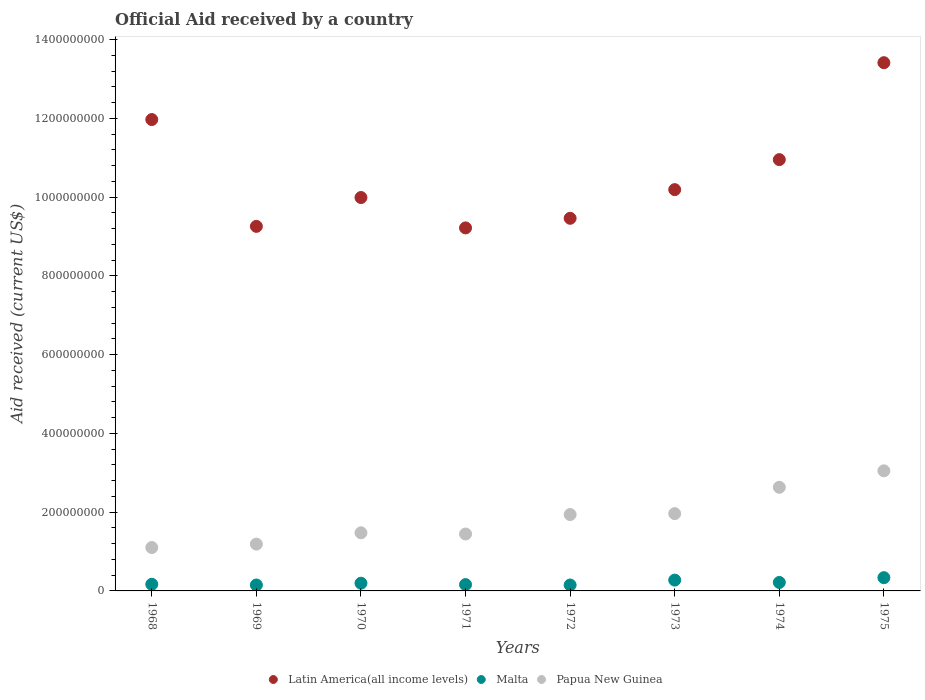How many different coloured dotlines are there?
Offer a terse response. 3. What is the net official aid received in Malta in 1971?
Provide a succinct answer. 1.60e+07. Across all years, what is the maximum net official aid received in Malta?
Your answer should be very brief. 3.36e+07. Across all years, what is the minimum net official aid received in Malta?
Give a very brief answer. 1.50e+07. In which year was the net official aid received in Malta maximum?
Give a very brief answer. 1975. In which year was the net official aid received in Malta minimum?
Offer a very short reply. 1972. What is the total net official aid received in Papua New Guinea in the graph?
Provide a short and direct response. 1.48e+09. What is the difference between the net official aid received in Latin America(all income levels) in 1972 and that in 1975?
Offer a terse response. -3.95e+08. What is the difference between the net official aid received in Latin America(all income levels) in 1971 and the net official aid received in Papua New Guinea in 1968?
Provide a short and direct response. 8.12e+08. What is the average net official aid received in Latin America(all income levels) per year?
Your answer should be compact. 1.06e+09. In the year 1971, what is the difference between the net official aid received in Malta and net official aid received in Papua New Guinea?
Your answer should be very brief. -1.29e+08. In how many years, is the net official aid received in Malta greater than 1320000000 US$?
Make the answer very short. 0. What is the ratio of the net official aid received in Latin America(all income levels) in 1968 to that in 1969?
Keep it short and to the point. 1.29. Is the net official aid received in Malta in 1970 less than that in 1975?
Give a very brief answer. Yes. Is the difference between the net official aid received in Malta in 1968 and 1970 greater than the difference between the net official aid received in Papua New Guinea in 1968 and 1970?
Your answer should be compact. Yes. What is the difference between the highest and the second highest net official aid received in Malta?
Make the answer very short. 6.16e+06. What is the difference between the highest and the lowest net official aid received in Papua New Guinea?
Provide a succinct answer. 1.95e+08. In how many years, is the net official aid received in Latin America(all income levels) greater than the average net official aid received in Latin America(all income levels) taken over all years?
Provide a short and direct response. 3. Is the sum of the net official aid received in Malta in 1970 and 1973 greater than the maximum net official aid received in Papua New Guinea across all years?
Your response must be concise. No. Is it the case that in every year, the sum of the net official aid received in Malta and net official aid received in Latin America(all income levels)  is greater than the net official aid received in Papua New Guinea?
Ensure brevity in your answer.  Yes. Is the net official aid received in Malta strictly greater than the net official aid received in Latin America(all income levels) over the years?
Ensure brevity in your answer.  No. How many dotlines are there?
Your answer should be very brief. 3. Where does the legend appear in the graph?
Your response must be concise. Bottom center. How many legend labels are there?
Your answer should be compact. 3. What is the title of the graph?
Your response must be concise. Official Aid received by a country. What is the label or title of the X-axis?
Offer a terse response. Years. What is the label or title of the Y-axis?
Ensure brevity in your answer.  Aid received (current US$). What is the Aid received (current US$) in Latin America(all income levels) in 1968?
Keep it short and to the point. 1.20e+09. What is the Aid received (current US$) in Malta in 1968?
Offer a very short reply. 1.68e+07. What is the Aid received (current US$) in Papua New Guinea in 1968?
Make the answer very short. 1.10e+08. What is the Aid received (current US$) of Latin America(all income levels) in 1969?
Offer a terse response. 9.26e+08. What is the Aid received (current US$) in Malta in 1969?
Provide a short and direct response. 1.50e+07. What is the Aid received (current US$) of Papua New Guinea in 1969?
Your answer should be very brief. 1.19e+08. What is the Aid received (current US$) of Latin America(all income levels) in 1970?
Your answer should be very brief. 9.99e+08. What is the Aid received (current US$) of Malta in 1970?
Ensure brevity in your answer.  1.96e+07. What is the Aid received (current US$) in Papua New Guinea in 1970?
Offer a very short reply. 1.48e+08. What is the Aid received (current US$) in Latin America(all income levels) in 1971?
Your answer should be compact. 9.22e+08. What is the Aid received (current US$) in Malta in 1971?
Your answer should be very brief. 1.60e+07. What is the Aid received (current US$) of Papua New Guinea in 1971?
Your response must be concise. 1.45e+08. What is the Aid received (current US$) in Latin America(all income levels) in 1972?
Your answer should be compact. 9.46e+08. What is the Aid received (current US$) in Malta in 1972?
Your response must be concise. 1.50e+07. What is the Aid received (current US$) in Papua New Guinea in 1972?
Your answer should be very brief. 1.94e+08. What is the Aid received (current US$) of Latin America(all income levels) in 1973?
Give a very brief answer. 1.02e+09. What is the Aid received (current US$) of Malta in 1973?
Keep it short and to the point. 2.75e+07. What is the Aid received (current US$) of Papua New Guinea in 1973?
Provide a succinct answer. 1.96e+08. What is the Aid received (current US$) in Latin America(all income levels) in 1974?
Offer a terse response. 1.10e+09. What is the Aid received (current US$) of Malta in 1974?
Your answer should be very brief. 2.15e+07. What is the Aid received (current US$) in Papua New Guinea in 1974?
Offer a very short reply. 2.63e+08. What is the Aid received (current US$) of Latin America(all income levels) in 1975?
Provide a succinct answer. 1.34e+09. What is the Aid received (current US$) in Malta in 1975?
Ensure brevity in your answer.  3.36e+07. What is the Aid received (current US$) of Papua New Guinea in 1975?
Make the answer very short. 3.05e+08. Across all years, what is the maximum Aid received (current US$) in Latin America(all income levels)?
Keep it short and to the point. 1.34e+09. Across all years, what is the maximum Aid received (current US$) in Malta?
Provide a short and direct response. 3.36e+07. Across all years, what is the maximum Aid received (current US$) of Papua New Guinea?
Keep it short and to the point. 3.05e+08. Across all years, what is the minimum Aid received (current US$) of Latin America(all income levels)?
Offer a terse response. 9.22e+08. Across all years, what is the minimum Aid received (current US$) in Malta?
Give a very brief answer. 1.50e+07. Across all years, what is the minimum Aid received (current US$) in Papua New Guinea?
Offer a terse response. 1.10e+08. What is the total Aid received (current US$) of Latin America(all income levels) in the graph?
Keep it short and to the point. 8.45e+09. What is the total Aid received (current US$) of Malta in the graph?
Keep it short and to the point. 1.65e+08. What is the total Aid received (current US$) of Papua New Guinea in the graph?
Offer a very short reply. 1.48e+09. What is the difference between the Aid received (current US$) of Latin America(all income levels) in 1968 and that in 1969?
Give a very brief answer. 2.71e+08. What is the difference between the Aid received (current US$) of Malta in 1968 and that in 1969?
Your response must be concise. 1.80e+06. What is the difference between the Aid received (current US$) of Papua New Guinea in 1968 and that in 1969?
Give a very brief answer. -8.67e+06. What is the difference between the Aid received (current US$) of Latin America(all income levels) in 1968 and that in 1970?
Give a very brief answer. 1.98e+08. What is the difference between the Aid received (current US$) in Malta in 1968 and that in 1970?
Ensure brevity in your answer.  -2.71e+06. What is the difference between the Aid received (current US$) in Papua New Guinea in 1968 and that in 1970?
Your answer should be compact. -3.74e+07. What is the difference between the Aid received (current US$) in Latin America(all income levels) in 1968 and that in 1971?
Your answer should be very brief. 2.75e+08. What is the difference between the Aid received (current US$) of Malta in 1968 and that in 1971?
Offer a terse response. 8.10e+05. What is the difference between the Aid received (current US$) in Papua New Guinea in 1968 and that in 1971?
Provide a short and direct response. -3.43e+07. What is the difference between the Aid received (current US$) of Latin America(all income levels) in 1968 and that in 1972?
Ensure brevity in your answer.  2.51e+08. What is the difference between the Aid received (current US$) in Malta in 1968 and that in 1972?
Your answer should be very brief. 1.81e+06. What is the difference between the Aid received (current US$) in Papua New Guinea in 1968 and that in 1972?
Offer a terse response. -8.37e+07. What is the difference between the Aid received (current US$) of Latin America(all income levels) in 1968 and that in 1973?
Offer a very short reply. 1.78e+08. What is the difference between the Aid received (current US$) in Malta in 1968 and that in 1973?
Provide a succinct answer. -1.06e+07. What is the difference between the Aid received (current US$) of Papua New Guinea in 1968 and that in 1973?
Give a very brief answer. -8.61e+07. What is the difference between the Aid received (current US$) in Latin America(all income levels) in 1968 and that in 1974?
Provide a succinct answer. 1.02e+08. What is the difference between the Aid received (current US$) in Malta in 1968 and that in 1974?
Your answer should be very brief. -4.68e+06. What is the difference between the Aid received (current US$) of Papua New Guinea in 1968 and that in 1974?
Your answer should be very brief. -1.53e+08. What is the difference between the Aid received (current US$) of Latin America(all income levels) in 1968 and that in 1975?
Offer a very short reply. -1.44e+08. What is the difference between the Aid received (current US$) in Malta in 1968 and that in 1975?
Provide a short and direct response. -1.68e+07. What is the difference between the Aid received (current US$) in Papua New Guinea in 1968 and that in 1975?
Provide a short and direct response. -1.95e+08. What is the difference between the Aid received (current US$) in Latin America(all income levels) in 1969 and that in 1970?
Your answer should be very brief. -7.33e+07. What is the difference between the Aid received (current US$) in Malta in 1969 and that in 1970?
Keep it short and to the point. -4.51e+06. What is the difference between the Aid received (current US$) in Papua New Guinea in 1969 and that in 1970?
Make the answer very short. -2.88e+07. What is the difference between the Aid received (current US$) in Latin America(all income levels) in 1969 and that in 1971?
Keep it short and to the point. 3.88e+06. What is the difference between the Aid received (current US$) in Malta in 1969 and that in 1971?
Your answer should be compact. -9.90e+05. What is the difference between the Aid received (current US$) of Papua New Guinea in 1969 and that in 1971?
Provide a succinct answer. -2.57e+07. What is the difference between the Aid received (current US$) of Latin America(all income levels) in 1969 and that in 1972?
Offer a very short reply. -2.05e+07. What is the difference between the Aid received (current US$) of Malta in 1969 and that in 1972?
Your answer should be compact. 10000. What is the difference between the Aid received (current US$) of Papua New Guinea in 1969 and that in 1972?
Make the answer very short. -7.51e+07. What is the difference between the Aid received (current US$) in Latin America(all income levels) in 1969 and that in 1973?
Provide a short and direct response. -9.33e+07. What is the difference between the Aid received (current US$) of Malta in 1969 and that in 1973?
Your answer should be compact. -1.24e+07. What is the difference between the Aid received (current US$) in Papua New Guinea in 1969 and that in 1973?
Keep it short and to the point. -7.74e+07. What is the difference between the Aid received (current US$) of Latin America(all income levels) in 1969 and that in 1974?
Your answer should be very brief. -1.70e+08. What is the difference between the Aid received (current US$) of Malta in 1969 and that in 1974?
Provide a short and direct response. -6.48e+06. What is the difference between the Aid received (current US$) of Papua New Guinea in 1969 and that in 1974?
Make the answer very short. -1.44e+08. What is the difference between the Aid received (current US$) of Latin America(all income levels) in 1969 and that in 1975?
Provide a succinct answer. -4.16e+08. What is the difference between the Aid received (current US$) of Malta in 1969 and that in 1975?
Offer a terse response. -1.86e+07. What is the difference between the Aid received (current US$) in Papua New Guinea in 1969 and that in 1975?
Give a very brief answer. -1.86e+08. What is the difference between the Aid received (current US$) of Latin America(all income levels) in 1970 and that in 1971?
Provide a short and direct response. 7.72e+07. What is the difference between the Aid received (current US$) in Malta in 1970 and that in 1971?
Provide a short and direct response. 3.52e+06. What is the difference between the Aid received (current US$) of Papua New Guinea in 1970 and that in 1971?
Provide a succinct answer. 3.10e+06. What is the difference between the Aid received (current US$) of Latin America(all income levels) in 1970 and that in 1972?
Your response must be concise. 5.28e+07. What is the difference between the Aid received (current US$) in Malta in 1970 and that in 1972?
Your response must be concise. 4.52e+06. What is the difference between the Aid received (current US$) of Papua New Guinea in 1970 and that in 1972?
Your response must be concise. -4.63e+07. What is the difference between the Aid received (current US$) of Latin America(all income levels) in 1970 and that in 1973?
Provide a succinct answer. -2.01e+07. What is the difference between the Aid received (current US$) in Malta in 1970 and that in 1973?
Make the answer very short. -7.93e+06. What is the difference between the Aid received (current US$) in Papua New Guinea in 1970 and that in 1973?
Give a very brief answer. -4.87e+07. What is the difference between the Aid received (current US$) in Latin America(all income levels) in 1970 and that in 1974?
Make the answer very short. -9.63e+07. What is the difference between the Aid received (current US$) in Malta in 1970 and that in 1974?
Offer a terse response. -1.97e+06. What is the difference between the Aid received (current US$) of Papua New Guinea in 1970 and that in 1974?
Keep it short and to the point. -1.16e+08. What is the difference between the Aid received (current US$) in Latin America(all income levels) in 1970 and that in 1975?
Offer a terse response. -3.42e+08. What is the difference between the Aid received (current US$) in Malta in 1970 and that in 1975?
Provide a succinct answer. -1.41e+07. What is the difference between the Aid received (current US$) in Papua New Guinea in 1970 and that in 1975?
Provide a short and direct response. -1.57e+08. What is the difference between the Aid received (current US$) in Latin America(all income levels) in 1971 and that in 1972?
Provide a succinct answer. -2.44e+07. What is the difference between the Aid received (current US$) in Papua New Guinea in 1971 and that in 1972?
Ensure brevity in your answer.  -4.94e+07. What is the difference between the Aid received (current US$) of Latin America(all income levels) in 1971 and that in 1973?
Ensure brevity in your answer.  -9.72e+07. What is the difference between the Aid received (current US$) of Malta in 1971 and that in 1973?
Your answer should be compact. -1.14e+07. What is the difference between the Aid received (current US$) of Papua New Guinea in 1971 and that in 1973?
Provide a short and direct response. -5.18e+07. What is the difference between the Aid received (current US$) in Latin America(all income levels) in 1971 and that in 1974?
Make the answer very short. -1.73e+08. What is the difference between the Aid received (current US$) of Malta in 1971 and that in 1974?
Provide a succinct answer. -5.49e+06. What is the difference between the Aid received (current US$) of Papua New Guinea in 1971 and that in 1974?
Ensure brevity in your answer.  -1.19e+08. What is the difference between the Aid received (current US$) in Latin America(all income levels) in 1971 and that in 1975?
Your answer should be compact. -4.20e+08. What is the difference between the Aid received (current US$) of Malta in 1971 and that in 1975?
Your answer should be very brief. -1.76e+07. What is the difference between the Aid received (current US$) of Papua New Guinea in 1971 and that in 1975?
Provide a short and direct response. -1.60e+08. What is the difference between the Aid received (current US$) of Latin America(all income levels) in 1972 and that in 1973?
Provide a short and direct response. -7.28e+07. What is the difference between the Aid received (current US$) in Malta in 1972 and that in 1973?
Offer a very short reply. -1.24e+07. What is the difference between the Aid received (current US$) in Papua New Guinea in 1972 and that in 1973?
Offer a very short reply. -2.37e+06. What is the difference between the Aid received (current US$) of Latin America(all income levels) in 1972 and that in 1974?
Your answer should be compact. -1.49e+08. What is the difference between the Aid received (current US$) of Malta in 1972 and that in 1974?
Offer a terse response. -6.49e+06. What is the difference between the Aid received (current US$) of Papua New Guinea in 1972 and that in 1974?
Make the answer very short. -6.92e+07. What is the difference between the Aid received (current US$) in Latin America(all income levels) in 1972 and that in 1975?
Make the answer very short. -3.95e+08. What is the difference between the Aid received (current US$) in Malta in 1972 and that in 1975?
Your answer should be compact. -1.86e+07. What is the difference between the Aid received (current US$) of Papua New Guinea in 1972 and that in 1975?
Offer a very short reply. -1.11e+08. What is the difference between the Aid received (current US$) of Latin America(all income levels) in 1973 and that in 1974?
Your answer should be very brief. -7.62e+07. What is the difference between the Aid received (current US$) of Malta in 1973 and that in 1974?
Give a very brief answer. 5.96e+06. What is the difference between the Aid received (current US$) in Papua New Guinea in 1973 and that in 1974?
Make the answer very short. -6.68e+07. What is the difference between the Aid received (current US$) of Latin America(all income levels) in 1973 and that in 1975?
Offer a very short reply. -3.22e+08. What is the difference between the Aid received (current US$) of Malta in 1973 and that in 1975?
Provide a short and direct response. -6.16e+06. What is the difference between the Aid received (current US$) in Papua New Guinea in 1973 and that in 1975?
Provide a succinct answer. -1.09e+08. What is the difference between the Aid received (current US$) of Latin America(all income levels) in 1974 and that in 1975?
Keep it short and to the point. -2.46e+08. What is the difference between the Aid received (current US$) in Malta in 1974 and that in 1975?
Offer a very short reply. -1.21e+07. What is the difference between the Aid received (current US$) in Papua New Guinea in 1974 and that in 1975?
Give a very brief answer. -4.18e+07. What is the difference between the Aid received (current US$) in Latin America(all income levels) in 1968 and the Aid received (current US$) in Malta in 1969?
Your answer should be very brief. 1.18e+09. What is the difference between the Aid received (current US$) in Latin America(all income levels) in 1968 and the Aid received (current US$) in Papua New Guinea in 1969?
Provide a succinct answer. 1.08e+09. What is the difference between the Aid received (current US$) in Malta in 1968 and the Aid received (current US$) in Papua New Guinea in 1969?
Provide a succinct answer. -1.02e+08. What is the difference between the Aid received (current US$) of Latin America(all income levels) in 1968 and the Aid received (current US$) of Malta in 1970?
Provide a succinct answer. 1.18e+09. What is the difference between the Aid received (current US$) in Latin America(all income levels) in 1968 and the Aid received (current US$) in Papua New Guinea in 1970?
Keep it short and to the point. 1.05e+09. What is the difference between the Aid received (current US$) in Malta in 1968 and the Aid received (current US$) in Papua New Guinea in 1970?
Your answer should be very brief. -1.31e+08. What is the difference between the Aid received (current US$) in Latin America(all income levels) in 1968 and the Aid received (current US$) in Malta in 1971?
Make the answer very short. 1.18e+09. What is the difference between the Aid received (current US$) of Latin America(all income levels) in 1968 and the Aid received (current US$) of Papua New Guinea in 1971?
Your answer should be compact. 1.05e+09. What is the difference between the Aid received (current US$) of Malta in 1968 and the Aid received (current US$) of Papua New Guinea in 1971?
Provide a succinct answer. -1.28e+08. What is the difference between the Aid received (current US$) of Latin America(all income levels) in 1968 and the Aid received (current US$) of Malta in 1972?
Make the answer very short. 1.18e+09. What is the difference between the Aid received (current US$) in Latin America(all income levels) in 1968 and the Aid received (current US$) in Papua New Guinea in 1972?
Provide a short and direct response. 1.00e+09. What is the difference between the Aid received (current US$) in Malta in 1968 and the Aid received (current US$) in Papua New Guinea in 1972?
Ensure brevity in your answer.  -1.77e+08. What is the difference between the Aid received (current US$) of Latin America(all income levels) in 1968 and the Aid received (current US$) of Malta in 1973?
Provide a succinct answer. 1.17e+09. What is the difference between the Aid received (current US$) in Latin America(all income levels) in 1968 and the Aid received (current US$) in Papua New Guinea in 1973?
Your answer should be very brief. 1.00e+09. What is the difference between the Aid received (current US$) in Malta in 1968 and the Aid received (current US$) in Papua New Guinea in 1973?
Provide a succinct answer. -1.79e+08. What is the difference between the Aid received (current US$) of Latin America(all income levels) in 1968 and the Aid received (current US$) of Malta in 1974?
Give a very brief answer. 1.18e+09. What is the difference between the Aid received (current US$) of Latin America(all income levels) in 1968 and the Aid received (current US$) of Papua New Guinea in 1974?
Your answer should be compact. 9.34e+08. What is the difference between the Aid received (current US$) of Malta in 1968 and the Aid received (current US$) of Papua New Guinea in 1974?
Your response must be concise. -2.46e+08. What is the difference between the Aid received (current US$) of Latin America(all income levels) in 1968 and the Aid received (current US$) of Malta in 1975?
Make the answer very short. 1.16e+09. What is the difference between the Aid received (current US$) in Latin America(all income levels) in 1968 and the Aid received (current US$) in Papua New Guinea in 1975?
Offer a terse response. 8.92e+08. What is the difference between the Aid received (current US$) of Malta in 1968 and the Aid received (current US$) of Papua New Guinea in 1975?
Offer a terse response. -2.88e+08. What is the difference between the Aid received (current US$) of Latin America(all income levels) in 1969 and the Aid received (current US$) of Malta in 1970?
Make the answer very short. 9.06e+08. What is the difference between the Aid received (current US$) of Latin America(all income levels) in 1969 and the Aid received (current US$) of Papua New Guinea in 1970?
Your answer should be very brief. 7.78e+08. What is the difference between the Aid received (current US$) in Malta in 1969 and the Aid received (current US$) in Papua New Guinea in 1970?
Make the answer very short. -1.33e+08. What is the difference between the Aid received (current US$) in Latin America(all income levels) in 1969 and the Aid received (current US$) in Malta in 1971?
Give a very brief answer. 9.10e+08. What is the difference between the Aid received (current US$) of Latin America(all income levels) in 1969 and the Aid received (current US$) of Papua New Guinea in 1971?
Your answer should be compact. 7.81e+08. What is the difference between the Aid received (current US$) in Malta in 1969 and the Aid received (current US$) in Papua New Guinea in 1971?
Your response must be concise. -1.30e+08. What is the difference between the Aid received (current US$) of Latin America(all income levels) in 1969 and the Aid received (current US$) of Malta in 1972?
Provide a succinct answer. 9.11e+08. What is the difference between the Aid received (current US$) of Latin America(all income levels) in 1969 and the Aid received (current US$) of Papua New Guinea in 1972?
Keep it short and to the point. 7.32e+08. What is the difference between the Aid received (current US$) of Malta in 1969 and the Aid received (current US$) of Papua New Guinea in 1972?
Your response must be concise. -1.79e+08. What is the difference between the Aid received (current US$) in Latin America(all income levels) in 1969 and the Aid received (current US$) in Malta in 1973?
Offer a very short reply. 8.98e+08. What is the difference between the Aid received (current US$) in Latin America(all income levels) in 1969 and the Aid received (current US$) in Papua New Guinea in 1973?
Make the answer very short. 7.30e+08. What is the difference between the Aid received (current US$) of Malta in 1969 and the Aid received (current US$) of Papua New Guinea in 1973?
Offer a terse response. -1.81e+08. What is the difference between the Aid received (current US$) of Latin America(all income levels) in 1969 and the Aid received (current US$) of Malta in 1974?
Your response must be concise. 9.04e+08. What is the difference between the Aid received (current US$) in Latin America(all income levels) in 1969 and the Aid received (current US$) in Papua New Guinea in 1974?
Provide a succinct answer. 6.63e+08. What is the difference between the Aid received (current US$) in Malta in 1969 and the Aid received (current US$) in Papua New Guinea in 1974?
Ensure brevity in your answer.  -2.48e+08. What is the difference between the Aid received (current US$) of Latin America(all income levels) in 1969 and the Aid received (current US$) of Malta in 1975?
Provide a short and direct response. 8.92e+08. What is the difference between the Aid received (current US$) in Latin America(all income levels) in 1969 and the Aid received (current US$) in Papua New Guinea in 1975?
Provide a succinct answer. 6.21e+08. What is the difference between the Aid received (current US$) in Malta in 1969 and the Aid received (current US$) in Papua New Guinea in 1975?
Your answer should be compact. -2.90e+08. What is the difference between the Aid received (current US$) of Latin America(all income levels) in 1970 and the Aid received (current US$) of Malta in 1971?
Offer a very short reply. 9.83e+08. What is the difference between the Aid received (current US$) of Latin America(all income levels) in 1970 and the Aid received (current US$) of Papua New Guinea in 1971?
Keep it short and to the point. 8.55e+08. What is the difference between the Aid received (current US$) in Malta in 1970 and the Aid received (current US$) in Papua New Guinea in 1971?
Keep it short and to the point. -1.25e+08. What is the difference between the Aid received (current US$) of Latin America(all income levels) in 1970 and the Aid received (current US$) of Malta in 1972?
Keep it short and to the point. 9.84e+08. What is the difference between the Aid received (current US$) in Latin America(all income levels) in 1970 and the Aid received (current US$) in Papua New Guinea in 1972?
Offer a terse response. 8.05e+08. What is the difference between the Aid received (current US$) of Malta in 1970 and the Aid received (current US$) of Papua New Guinea in 1972?
Provide a short and direct response. -1.74e+08. What is the difference between the Aid received (current US$) in Latin America(all income levels) in 1970 and the Aid received (current US$) in Malta in 1973?
Give a very brief answer. 9.72e+08. What is the difference between the Aid received (current US$) in Latin America(all income levels) in 1970 and the Aid received (current US$) in Papua New Guinea in 1973?
Provide a short and direct response. 8.03e+08. What is the difference between the Aid received (current US$) in Malta in 1970 and the Aid received (current US$) in Papua New Guinea in 1973?
Your answer should be compact. -1.77e+08. What is the difference between the Aid received (current US$) in Latin America(all income levels) in 1970 and the Aid received (current US$) in Malta in 1974?
Offer a terse response. 9.78e+08. What is the difference between the Aid received (current US$) in Latin America(all income levels) in 1970 and the Aid received (current US$) in Papua New Guinea in 1974?
Your response must be concise. 7.36e+08. What is the difference between the Aid received (current US$) in Malta in 1970 and the Aid received (current US$) in Papua New Guinea in 1974?
Your response must be concise. -2.44e+08. What is the difference between the Aid received (current US$) in Latin America(all income levels) in 1970 and the Aid received (current US$) in Malta in 1975?
Make the answer very short. 9.66e+08. What is the difference between the Aid received (current US$) in Latin America(all income levels) in 1970 and the Aid received (current US$) in Papua New Guinea in 1975?
Ensure brevity in your answer.  6.94e+08. What is the difference between the Aid received (current US$) of Malta in 1970 and the Aid received (current US$) of Papua New Guinea in 1975?
Offer a terse response. -2.85e+08. What is the difference between the Aid received (current US$) in Latin America(all income levels) in 1971 and the Aid received (current US$) in Malta in 1972?
Your answer should be compact. 9.07e+08. What is the difference between the Aid received (current US$) in Latin America(all income levels) in 1971 and the Aid received (current US$) in Papua New Guinea in 1972?
Provide a succinct answer. 7.28e+08. What is the difference between the Aid received (current US$) in Malta in 1971 and the Aid received (current US$) in Papua New Guinea in 1972?
Provide a succinct answer. -1.78e+08. What is the difference between the Aid received (current US$) in Latin America(all income levels) in 1971 and the Aid received (current US$) in Malta in 1973?
Give a very brief answer. 8.95e+08. What is the difference between the Aid received (current US$) in Latin America(all income levels) in 1971 and the Aid received (current US$) in Papua New Guinea in 1973?
Your response must be concise. 7.26e+08. What is the difference between the Aid received (current US$) of Malta in 1971 and the Aid received (current US$) of Papua New Guinea in 1973?
Keep it short and to the point. -1.80e+08. What is the difference between the Aid received (current US$) of Latin America(all income levels) in 1971 and the Aid received (current US$) of Malta in 1974?
Make the answer very short. 9.00e+08. What is the difference between the Aid received (current US$) in Latin America(all income levels) in 1971 and the Aid received (current US$) in Papua New Guinea in 1974?
Your answer should be very brief. 6.59e+08. What is the difference between the Aid received (current US$) in Malta in 1971 and the Aid received (current US$) in Papua New Guinea in 1974?
Offer a terse response. -2.47e+08. What is the difference between the Aid received (current US$) of Latin America(all income levels) in 1971 and the Aid received (current US$) of Malta in 1975?
Give a very brief answer. 8.88e+08. What is the difference between the Aid received (current US$) of Latin America(all income levels) in 1971 and the Aid received (current US$) of Papua New Guinea in 1975?
Make the answer very short. 6.17e+08. What is the difference between the Aid received (current US$) in Malta in 1971 and the Aid received (current US$) in Papua New Guinea in 1975?
Make the answer very short. -2.89e+08. What is the difference between the Aid received (current US$) of Latin America(all income levels) in 1972 and the Aid received (current US$) of Malta in 1973?
Ensure brevity in your answer.  9.19e+08. What is the difference between the Aid received (current US$) in Latin America(all income levels) in 1972 and the Aid received (current US$) in Papua New Guinea in 1973?
Offer a terse response. 7.50e+08. What is the difference between the Aid received (current US$) of Malta in 1972 and the Aid received (current US$) of Papua New Guinea in 1973?
Offer a terse response. -1.81e+08. What is the difference between the Aid received (current US$) of Latin America(all income levels) in 1972 and the Aid received (current US$) of Malta in 1974?
Offer a very short reply. 9.25e+08. What is the difference between the Aid received (current US$) of Latin America(all income levels) in 1972 and the Aid received (current US$) of Papua New Guinea in 1974?
Provide a succinct answer. 6.83e+08. What is the difference between the Aid received (current US$) of Malta in 1972 and the Aid received (current US$) of Papua New Guinea in 1974?
Provide a short and direct response. -2.48e+08. What is the difference between the Aid received (current US$) of Latin America(all income levels) in 1972 and the Aid received (current US$) of Malta in 1975?
Your answer should be very brief. 9.13e+08. What is the difference between the Aid received (current US$) in Latin America(all income levels) in 1972 and the Aid received (current US$) in Papua New Guinea in 1975?
Your response must be concise. 6.41e+08. What is the difference between the Aid received (current US$) of Malta in 1972 and the Aid received (current US$) of Papua New Guinea in 1975?
Ensure brevity in your answer.  -2.90e+08. What is the difference between the Aid received (current US$) in Latin America(all income levels) in 1973 and the Aid received (current US$) in Malta in 1974?
Give a very brief answer. 9.98e+08. What is the difference between the Aid received (current US$) of Latin America(all income levels) in 1973 and the Aid received (current US$) of Papua New Guinea in 1974?
Provide a short and direct response. 7.56e+08. What is the difference between the Aid received (current US$) in Malta in 1973 and the Aid received (current US$) in Papua New Guinea in 1974?
Make the answer very short. -2.36e+08. What is the difference between the Aid received (current US$) in Latin America(all income levels) in 1973 and the Aid received (current US$) in Malta in 1975?
Provide a short and direct response. 9.86e+08. What is the difference between the Aid received (current US$) in Latin America(all income levels) in 1973 and the Aid received (current US$) in Papua New Guinea in 1975?
Your answer should be very brief. 7.14e+08. What is the difference between the Aid received (current US$) in Malta in 1973 and the Aid received (current US$) in Papua New Guinea in 1975?
Give a very brief answer. -2.78e+08. What is the difference between the Aid received (current US$) of Latin America(all income levels) in 1974 and the Aid received (current US$) of Malta in 1975?
Make the answer very short. 1.06e+09. What is the difference between the Aid received (current US$) of Latin America(all income levels) in 1974 and the Aid received (current US$) of Papua New Guinea in 1975?
Make the answer very short. 7.90e+08. What is the difference between the Aid received (current US$) in Malta in 1974 and the Aid received (current US$) in Papua New Guinea in 1975?
Your answer should be very brief. -2.83e+08. What is the average Aid received (current US$) in Latin America(all income levels) per year?
Your answer should be compact. 1.06e+09. What is the average Aid received (current US$) in Malta per year?
Offer a very short reply. 2.07e+07. What is the average Aid received (current US$) in Papua New Guinea per year?
Your response must be concise. 1.85e+08. In the year 1968, what is the difference between the Aid received (current US$) of Latin America(all income levels) and Aid received (current US$) of Malta?
Ensure brevity in your answer.  1.18e+09. In the year 1968, what is the difference between the Aid received (current US$) of Latin America(all income levels) and Aid received (current US$) of Papua New Guinea?
Your response must be concise. 1.09e+09. In the year 1968, what is the difference between the Aid received (current US$) of Malta and Aid received (current US$) of Papua New Guinea?
Give a very brief answer. -9.34e+07. In the year 1969, what is the difference between the Aid received (current US$) of Latin America(all income levels) and Aid received (current US$) of Malta?
Offer a very short reply. 9.11e+08. In the year 1969, what is the difference between the Aid received (current US$) of Latin America(all income levels) and Aid received (current US$) of Papua New Guinea?
Keep it short and to the point. 8.07e+08. In the year 1969, what is the difference between the Aid received (current US$) in Malta and Aid received (current US$) in Papua New Guinea?
Keep it short and to the point. -1.04e+08. In the year 1970, what is the difference between the Aid received (current US$) of Latin America(all income levels) and Aid received (current US$) of Malta?
Make the answer very short. 9.80e+08. In the year 1970, what is the difference between the Aid received (current US$) in Latin America(all income levels) and Aid received (current US$) in Papua New Guinea?
Provide a short and direct response. 8.51e+08. In the year 1970, what is the difference between the Aid received (current US$) of Malta and Aid received (current US$) of Papua New Guinea?
Keep it short and to the point. -1.28e+08. In the year 1971, what is the difference between the Aid received (current US$) of Latin America(all income levels) and Aid received (current US$) of Malta?
Keep it short and to the point. 9.06e+08. In the year 1971, what is the difference between the Aid received (current US$) in Latin America(all income levels) and Aid received (current US$) in Papua New Guinea?
Keep it short and to the point. 7.77e+08. In the year 1971, what is the difference between the Aid received (current US$) of Malta and Aid received (current US$) of Papua New Guinea?
Keep it short and to the point. -1.29e+08. In the year 1972, what is the difference between the Aid received (current US$) of Latin America(all income levels) and Aid received (current US$) of Malta?
Provide a short and direct response. 9.31e+08. In the year 1972, what is the difference between the Aid received (current US$) of Latin America(all income levels) and Aid received (current US$) of Papua New Guinea?
Make the answer very short. 7.52e+08. In the year 1972, what is the difference between the Aid received (current US$) of Malta and Aid received (current US$) of Papua New Guinea?
Your answer should be very brief. -1.79e+08. In the year 1973, what is the difference between the Aid received (current US$) in Latin America(all income levels) and Aid received (current US$) in Malta?
Your answer should be very brief. 9.92e+08. In the year 1973, what is the difference between the Aid received (current US$) of Latin America(all income levels) and Aid received (current US$) of Papua New Guinea?
Offer a terse response. 8.23e+08. In the year 1973, what is the difference between the Aid received (current US$) of Malta and Aid received (current US$) of Papua New Guinea?
Your response must be concise. -1.69e+08. In the year 1974, what is the difference between the Aid received (current US$) in Latin America(all income levels) and Aid received (current US$) in Malta?
Your answer should be compact. 1.07e+09. In the year 1974, what is the difference between the Aid received (current US$) of Latin America(all income levels) and Aid received (current US$) of Papua New Guinea?
Your answer should be very brief. 8.32e+08. In the year 1974, what is the difference between the Aid received (current US$) of Malta and Aid received (current US$) of Papua New Guinea?
Your answer should be compact. -2.42e+08. In the year 1975, what is the difference between the Aid received (current US$) in Latin America(all income levels) and Aid received (current US$) in Malta?
Your response must be concise. 1.31e+09. In the year 1975, what is the difference between the Aid received (current US$) in Latin America(all income levels) and Aid received (current US$) in Papua New Guinea?
Offer a terse response. 1.04e+09. In the year 1975, what is the difference between the Aid received (current US$) of Malta and Aid received (current US$) of Papua New Guinea?
Provide a succinct answer. -2.71e+08. What is the ratio of the Aid received (current US$) in Latin America(all income levels) in 1968 to that in 1969?
Make the answer very short. 1.29. What is the ratio of the Aid received (current US$) of Malta in 1968 to that in 1969?
Provide a succinct answer. 1.12. What is the ratio of the Aid received (current US$) in Papua New Guinea in 1968 to that in 1969?
Your answer should be compact. 0.93. What is the ratio of the Aid received (current US$) of Latin America(all income levels) in 1968 to that in 1970?
Make the answer very short. 1.2. What is the ratio of the Aid received (current US$) in Malta in 1968 to that in 1970?
Your answer should be compact. 0.86. What is the ratio of the Aid received (current US$) in Papua New Guinea in 1968 to that in 1970?
Your answer should be very brief. 0.75. What is the ratio of the Aid received (current US$) in Latin America(all income levels) in 1968 to that in 1971?
Give a very brief answer. 1.3. What is the ratio of the Aid received (current US$) in Malta in 1968 to that in 1971?
Provide a succinct answer. 1.05. What is the ratio of the Aid received (current US$) in Papua New Guinea in 1968 to that in 1971?
Your response must be concise. 0.76. What is the ratio of the Aid received (current US$) in Latin America(all income levels) in 1968 to that in 1972?
Offer a terse response. 1.26. What is the ratio of the Aid received (current US$) of Malta in 1968 to that in 1972?
Offer a very short reply. 1.12. What is the ratio of the Aid received (current US$) of Papua New Guinea in 1968 to that in 1972?
Make the answer very short. 0.57. What is the ratio of the Aid received (current US$) in Latin America(all income levels) in 1968 to that in 1973?
Make the answer very short. 1.17. What is the ratio of the Aid received (current US$) of Malta in 1968 to that in 1973?
Offer a terse response. 0.61. What is the ratio of the Aid received (current US$) of Papua New Guinea in 1968 to that in 1973?
Your answer should be compact. 0.56. What is the ratio of the Aid received (current US$) in Latin America(all income levels) in 1968 to that in 1974?
Make the answer very short. 1.09. What is the ratio of the Aid received (current US$) in Malta in 1968 to that in 1974?
Make the answer very short. 0.78. What is the ratio of the Aid received (current US$) of Papua New Guinea in 1968 to that in 1974?
Your answer should be very brief. 0.42. What is the ratio of the Aid received (current US$) of Latin America(all income levels) in 1968 to that in 1975?
Your answer should be compact. 0.89. What is the ratio of the Aid received (current US$) in Malta in 1968 to that in 1975?
Offer a very short reply. 0.5. What is the ratio of the Aid received (current US$) in Papua New Guinea in 1968 to that in 1975?
Offer a terse response. 0.36. What is the ratio of the Aid received (current US$) of Latin America(all income levels) in 1969 to that in 1970?
Offer a very short reply. 0.93. What is the ratio of the Aid received (current US$) of Malta in 1969 to that in 1970?
Provide a succinct answer. 0.77. What is the ratio of the Aid received (current US$) in Papua New Guinea in 1969 to that in 1970?
Offer a terse response. 0.81. What is the ratio of the Aid received (current US$) in Latin America(all income levels) in 1969 to that in 1971?
Keep it short and to the point. 1. What is the ratio of the Aid received (current US$) in Malta in 1969 to that in 1971?
Offer a very short reply. 0.94. What is the ratio of the Aid received (current US$) in Papua New Guinea in 1969 to that in 1971?
Make the answer very short. 0.82. What is the ratio of the Aid received (current US$) of Latin America(all income levels) in 1969 to that in 1972?
Ensure brevity in your answer.  0.98. What is the ratio of the Aid received (current US$) in Malta in 1969 to that in 1972?
Provide a succinct answer. 1. What is the ratio of the Aid received (current US$) of Papua New Guinea in 1969 to that in 1972?
Your answer should be compact. 0.61. What is the ratio of the Aid received (current US$) in Latin America(all income levels) in 1969 to that in 1973?
Your answer should be very brief. 0.91. What is the ratio of the Aid received (current US$) of Malta in 1969 to that in 1973?
Your response must be concise. 0.55. What is the ratio of the Aid received (current US$) in Papua New Guinea in 1969 to that in 1973?
Offer a very short reply. 0.61. What is the ratio of the Aid received (current US$) of Latin America(all income levels) in 1969 to that in 1974?
Ensure brevity in your answer.  0.85. What is the ratio of the Aid received (current US$) in Malta in 1969 to that in 1974?
Give a very brief answer. 0.7. What is the ratio of the Aid received (current US$) of Papua New Guinea in 1969 to that in 1974?
Offer a terse response. 0.45. What is the ratio of the Aid received (current US$) of Latin America(all income levels) in 1969 to that in 1975?
Give a very brief answer. 0.69. What is the ratio of the Aid received (current US$) in Malta in 1969 to that in 1975?
Keep it short and to the point. 0.45. What is the ratio of the Aid received (current US$) of Papua New Guinea in 1969 to that in 1975?
Your answer should be very brief. 0.39. What is the ratio of the Aid received (current US$) of Latin America(all income levels) in 1970 to that in 1971?
Provide a short and direct response. 1.08. What is the ratio of the Aid received (current US$) in Malta in 1970 to that in 1971?
Provide a short and direct response. 1.22. What is the ratio of the Aid received (current US$) in Papua New Guinea in 1970 to that in 1971?
Provide a succinct answer. 1.02. What is the ratio of the Aid received (current US$) in Latin America(all income levels) in 1970 to that in 1972?
Offer a very short reply. 1.06. What is the ratio of the Aid received (current US$) in Malta in 1970 to that in 1972?
Give a very brief answer. 1.3. What is the ratio of the Aid received (current US$) of Papua New Guinea in 1970 to that in 1972?
Provide a short and direct response. 0.76. What is the ratio of the Aid received (current US$) in Latin America(all income levels) in 1970 to that in 1973?
Make the answer very short. 0.98. What is the ratio of the Aid received (current US$) of Malta in 1970 to that in 1973?
Your response must be concise. 0.71. What is the ratio of the Aid received (current US$) of Papua New Guinea in 1970 to that in 1973?
Your answer should be very brief. 0.75. What is the ratio of the Aid received (current US$) in Latin America(all income levels) in 1970 to that in 1974?
Your answer should be compact. 0.91. What is the ratio of the Aid received (current US$) of Malta in 1970 to that in 1974?
Offer a terse response. 0.91. What is the ratio of the Aid received (current US$) of Papua New Guinea in 1970 to that in 1974?
Your answer should be very brief. 0.56. What is the ratio of the Aid received (current US$) of Latin America(all income levels) in 1970 to that in 1975?
Provide a short and direct response. 0.74. What is the ratio of the Aid received (current US$) of Malta in 1970 to that in 1975?
Provide a short and direct response. 0.58. What is the ratio of the Aid received (current US$) in Papua New Guinea in 1970 to that in 1975?
Ensure brevity in your answer.  0.48. What is the ratio of the Aid received (current US$) in Latin America(all income levels) in 1971 to that in 1972?
Your answer should be very brief. 0.97. What is the ratio of the Aid received (current US$) in Malta in 1971 to that in 1972?
Provide a succinct answer. 1.07. What is the ratio of the Aid received (current US$) in Papua New Guinea in 1971 to that in 1972?
Provide a short and direct response. 0.75. What is the ratio of the Aid received (current US$) in Latin America(all income levels) in 1971 to that in 1973?
Ensure brevity in your answer.  0.9. What is the ratio of the Aid received (current US$) of Malta in 1971 to that in 1973?
Provide a succinct answer. 0.58. What is the ratio of the Aid received (current US$) in Papua New Guinea in 1971 to that in 1973?
Give a very brief answer. 0.74. What is the ratio of the Aid received (current US$) of Latin America(all income levels) in 1971 to that in 1974?
Provide a short and direct response. 0.84. What is the ratio of the Aid received (current US$) of Malta in 1971 to that in 1974?
Keep it short and to the point. 0.74. What is the ratio of the Aid received (current US$) in Papua New Guinea in 1971 to that in 1974?
Give a very brief answer. 0.55. What is the ratio of the Aid received (current US$) of Latin America(all income levels) in 1971 to that in 1975?
Your answer should be compact. 0.69. What is the ratio of the Aid received (current US$) of Malta in 1971 to that in 1975?
Ensure brevity in your answer.  0.48. What is the ratio of the Aid received (current US$) of Papua New Guinea in 1971 to that in 1975?
Keep it short and to the point. 0.47. What is the ratio of the Aid received (current US$) of Malta in 1972 to that in 1973?
Provide a short and direct response. 0.55. What is the ratio of the Aid received (current US$) in Papua New Guinea in 1972 to that in 1973?
Ensure brevity in your answer.  0.99. What is the ratio of the Aid received (current US$) of Latin America(all income levels) in 1972 to that in 1974?
Provide a short and direct response. 0.86. What is the ratio of the Aid received (current US$) in Malta in 1972 to that in 1974?
Ensure brevity in your answer.  0.7. What is the ratio of the Aid received (current US$) in Papua New Guinea in 1972 to that in 1974?
Ensure brevity in your answer.  0.74. What is the ratio of the Aid received (current US$) in Latin America(all income levels) in 1972 to that in 1975?
Keep it short and to the point. 0.71. What is the ratio of the Aid received (current US$) of Malta in 1972 to that in 1975?
Make the answer very short. 0.45. What is the ratio of the Aid received (current US$) in Papua New Guinea in 1972 to that in 1975?
Give a very brief answer. 0.64. What is the ratio of the Aid received (current US$) of Latin America(all income levels) in 1973 to that in 1974?
Provide a short and direct response. 0.93. What is the ratio of the Aid received (current US$) of Malta in 1973 to that in 1974?
Provide a short and direct response. 1.28. What is the ratio of the Aid received (current US$) of Papua New Guinea in 1973 to that in 1974?
Give a very brief answer. 0.75. What is the ratio of the Aid received (current US$) in Latin America(all income levels) in 1973 to that in 1975?
Your answer should be very brief. 0.76. What is the ratio of the Aid received (current US$) of Malta in 1973 to that in 1975?
Offer a terse response. 0.82. What is the ratio of the Aid received (current US$) of Papua New Guinea in 1973 to that in 1975?
Offer a very short reply. 0.64. What is the ratio of the Aid received (current US$) in Latin America(all income levels) in 1974 to that in 1975?
Provide a short and direct response. 0.82. What is the ratio of the Aid received (current US$) of Malta in 1974 to that in 1975?
Provide a short and direct response. 0.64. What is the ratio of the Aid received (current US$) of Papua New Guinea in 1974 to that in 1975?
Ensure brevity in your answer.  0.86. What is the difference between the highest and the second highest Aid received (current US$) in Latin America(all income levels)?
Your answer should be compact. 1.44e+08. What is the difference between the highest and the second highest Aid received (current US$) in Malta?
Ensure brevity in your answer.  6.16e+06. What is the difference between the highest and the second highest Aid received (current US$) of Papua New Guinea?
Your answer should be very brief. 4.18e+07. What is the difference between the highest and the lowest Aid received (current US$) in Latin America(all income levels)?
Your answer should be compact. 4.20e+08. What is the difference between the highest and the lowest Aid received (current US$) in Malta?
Offer a very short reply. 1.86e+07. What is the difference between the highest and the lowest Aid received (current US$) in Papua New Guinea?
Give a very brief answer. 1.95e+08. 